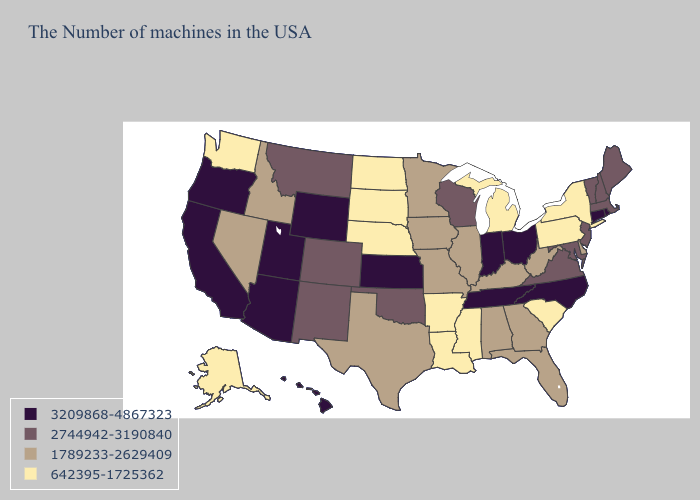Name the states that have a value in the range 3209868-4867323?
Give a very brief answer. Rhode Island, Connecticut, North Carolina, Ohio, Indiana, Tennessee, Kansas, Wyoming, Utah, Arizona, California, Oregon, Hawaii. Does New Jersey have the lowest value in the Northeast?
Concise answer only. No. Name the states that have a value in the range 642395-1725362?
Give a very brief answer. New York, Pennsylvania, South Carolina, Michigan, Mississippi, Louisiana, Arkansas, Nebraska, South Dakota, North Dakota, Washington, Alaska. Name the states that have a value in the range 3209868-4867323?
Write a very short answer. Rhode Island, Connecticut, North Carolina, Ohio, Indiana, Tennessee, Kansas, Wyoming, Utah, Arizona, California, Oregon, Hawaii. Name the states that have a value in the range 1789233-2629409?
Keep it brief. Delaware, West Virginia, Florida, Georgia, Kentucky, Alabama, Illinois, Missouri, Minnesota, Iowa, Texas, Idaho, Nevada. What is the value of Alabama?
Answer briefly. 1789233-2629409. What is the lowest value in the USA?
Concise answer only. 642395-1725362. Among the states that border Pennsylvania , does New Jersey have the highest value?
Quick response, please. No. Does Massachusetts have a lower value than Maine?
Short answer required. No. What is the value of Iowa?
Write a very short answer. 1789233-2629409. Does the map have missing data?
Quick response, please. No. What is the value of North Carolina?
Concise answer only. 3209868-4867323. Name the states that have a value in the range 2744942-3190840?
Answer briefly. Maine, Massachusetts, New Hampshire, Vermont, New Jersey, Maryland, Virginia, Wisconsin, Oklahoma, Colorado, New Mexico, Montana. What is the value of Delaware?
Quick response, please. 1789233-2629409. 